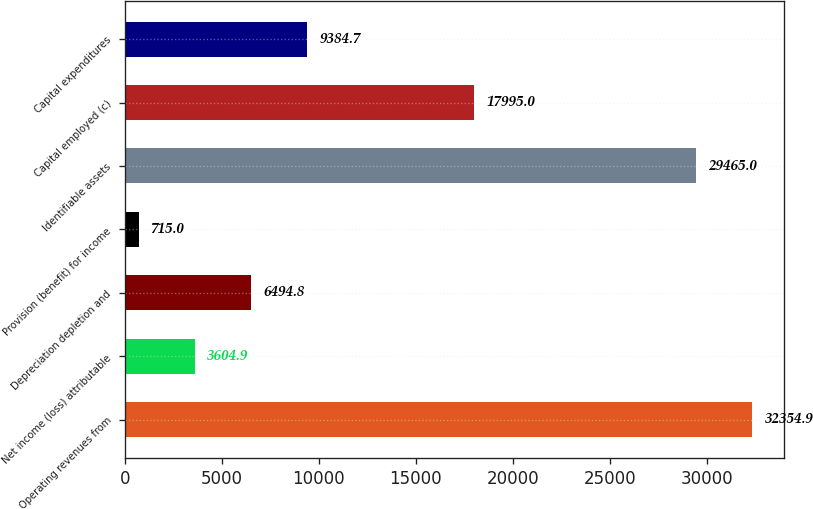<chart> <loc_0><loc_0><loc_500><loc_500><bar_chart><fcel>Operating revenues from<fcel>Net income (loss) attributable<fcel>Depreciation depletion and<fcel>Provision (benefit) for income<fcel>Identifiable assets<fcel>Capital employed (c)<fcel>Capital expenditures<nl><fcel>32354.9<fcel>3604.9<fcel>6494.8<fcel>715<fcel>29465<fcel>17995<fcel>9384.7<nl></chart> 